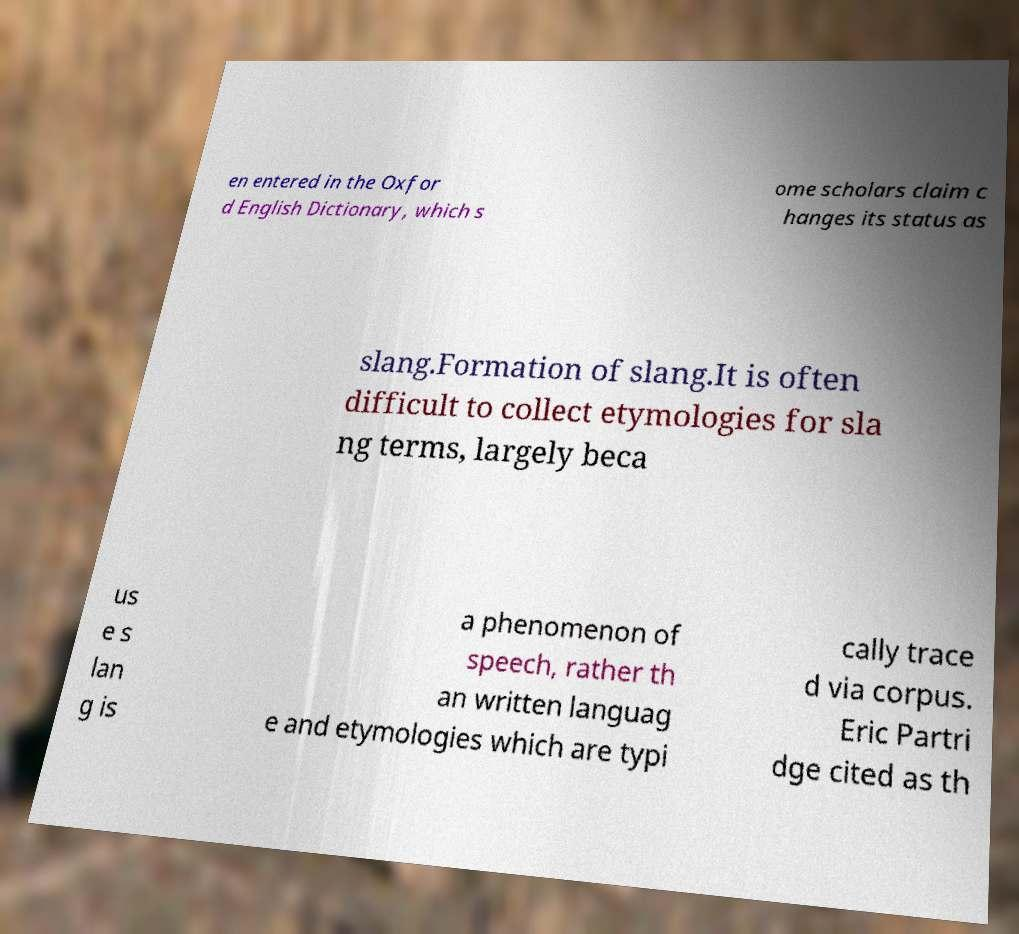There's text embedded in this image that I need extracted. Can you transcribe it verbatim? en entered in the Oxfor d English Dictionary, which s ome scholars claim c hanges its status as slang.Formation of slang.It is often difficult to collect etymologies for sla ng terms, largely beca us e s lan g is a phenomenon of speech, rather th an written languag e and etymologies which are typi cally trace d via corpus. Eric Partri dge cited as th 